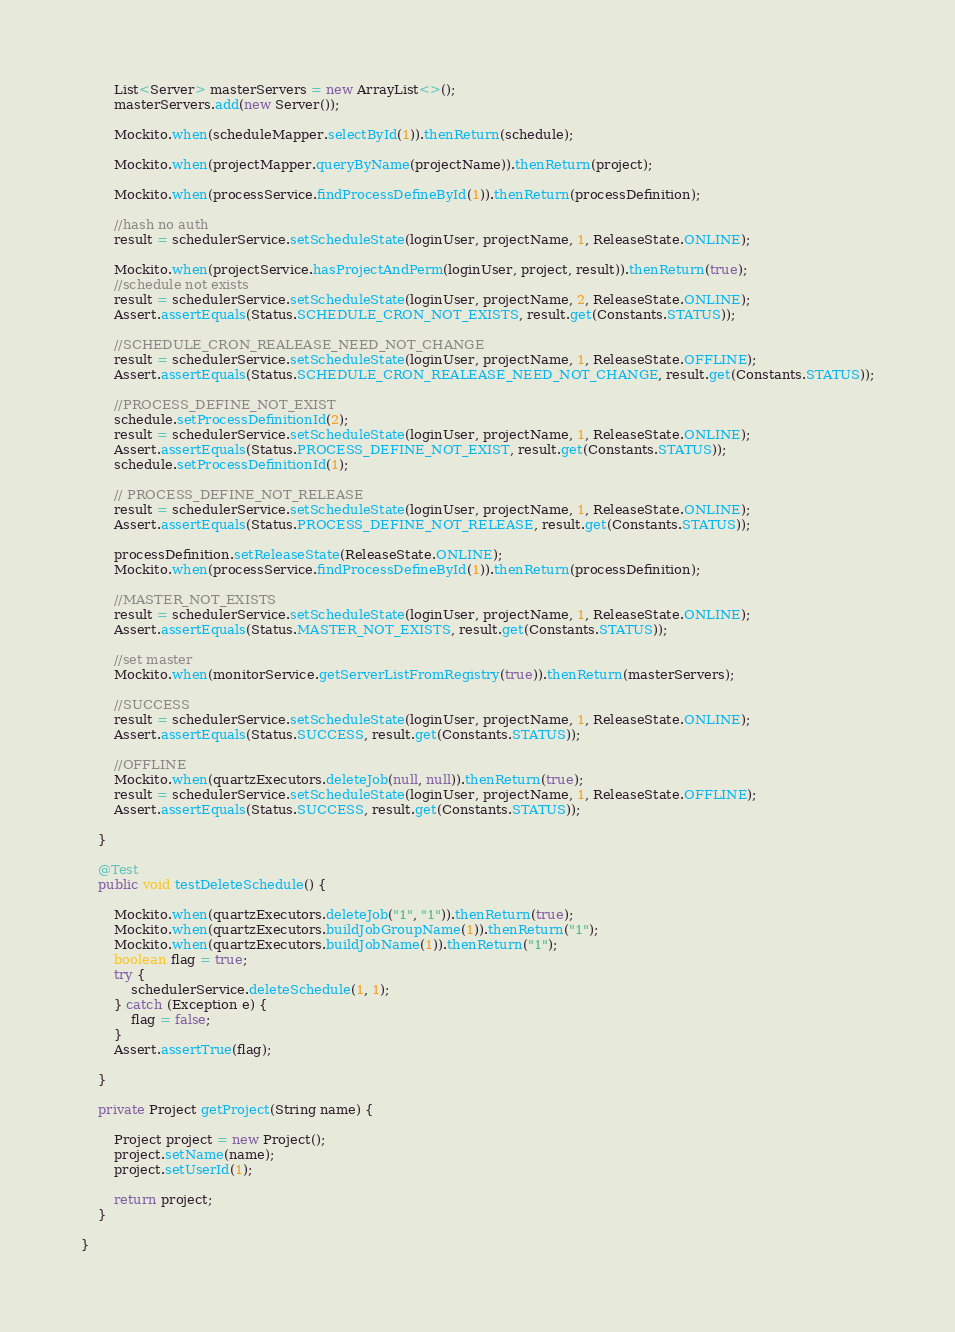Convert code to text. <code><loc_0><loc_0><loc_500><loc_500><_Java_>        List<Server> masterServers = new ArrayList<>();
        masterServers.add(new Server());

        Mockito.when(scheduleMapper.selectById(1)).thenReturn(schedule);

        Mockito.when(projectMapper.queryByName(projectName)).thenReturn(project);

        Mockito.when(processService.findProcessDefineById(1)).thenReturn(processDefinition);

        //hash no auth
        result = schedulerService.setScheduleState(loginUser, projectName, 1, ReleaseState.ONLINE);

        Mockito.when(projectService.hasProjectAndPerm(loginUser, project, result)).thenReturn(true);
        //schedule not exists
        result = schedulerService.setScheduleState(loginUser, projectName, 2, ReleaseState.ONLINE);
        Assert.assertEquals(Status.SCHEDULE_CRON_NOT_EXISTS, result.get(Constants.STATUS));

        //SCHEDULE_CRON_REALEASE_NEED_NOT_CHANGE
        result = schedulerService.setScheduleState(loginUser, projectName, 1, ReleaseState.OFFLINE);
        Assert.assertEquals(Status.SCHEDULE_CRON_REALEASE_NEED_NOT_CHANGE, result.get(Constants.STATUS));

        //PROCESS_DEFINE_NOT_EXIST
        schedule.setProcessDefinitionId(2);
        result = schedulerService.setScheduleState(loginUser, projectName, 1, ReleaseState.ONLINE);
        Assert.assertEquals(Status.PROCESS_DEFINE_NOT_EXIST, result.get(Constants.STATUS));
        schedule.setProcessDefinitionId(1);

        // PROCESS_DEFINE_NOT_RELEASE
        result = schedulerService.setScheduleState(loginUser, projectName, 1, ReleaseState.ONLINE);
        Assert.assertEquals(Status.PROCESS_DEFINE_NOT_RELEASE, result.get(Constants.STATUS));

        processDefinition.setReleaseState(ReleaseState.ONLINE);
        Mockito.when(processService.findProcessDefineById(1)).thenReturn(processDefinition);

        //MASTER_NOT_EXISTS
        result = schedulerService.setScheduleState(loginUser, projectName, 1, ReleaseState.ONLINE);
        Assert.assertEquals(Status.MASTER_NOT_EXISTS, result.get(Constants.STATUS));

        //set master
        Mockito.when(monitorService.getServerListFromRegistry(true)).thenReturn(masterServers);

        //SUCCESS
        result = schedulerService.setScheduleState(loginUser, projectName, 1, ReleaseState.ONLINE);
        Assert.assertEquals(Status.SUCCESS, result.get(Constants.STATUS));

        //OFFLINE
        Mockito.when(quartzExecutors.deleteJob(null, null)).thenReturn(true);
        result = schedulerService.setScheduleState(loginUser, projectName, 1, ReleaseState.OFFLINE);
        Assert.assertEquals(Status.SUCCESS, result.get(Constants.STATUS));

    }

    @Test
    public void testDeleteSchedule() {

        Mockito.when(quartzExecutors.deleteJob("1", "1")).thenReturn(true);
        Mockito.when(quartzExecutors.buildJobGroupName(1)).thenReturn("1");
        Mockito.when(quartzExecutors.buildJobName(1)).thenReturn("1");
        boolean flag = true;
        try {
            schedulerService.deleteSchedule(1, 1);
        } catch (Exception e) {
            flag = false;
        }
        Assert.assertTrue(flag);

    }

    private Project getProject(String name) {

        Project project = new Project();
        project.setName(name);
        project.setUserId(1);

        return project;
    }

}</code> 